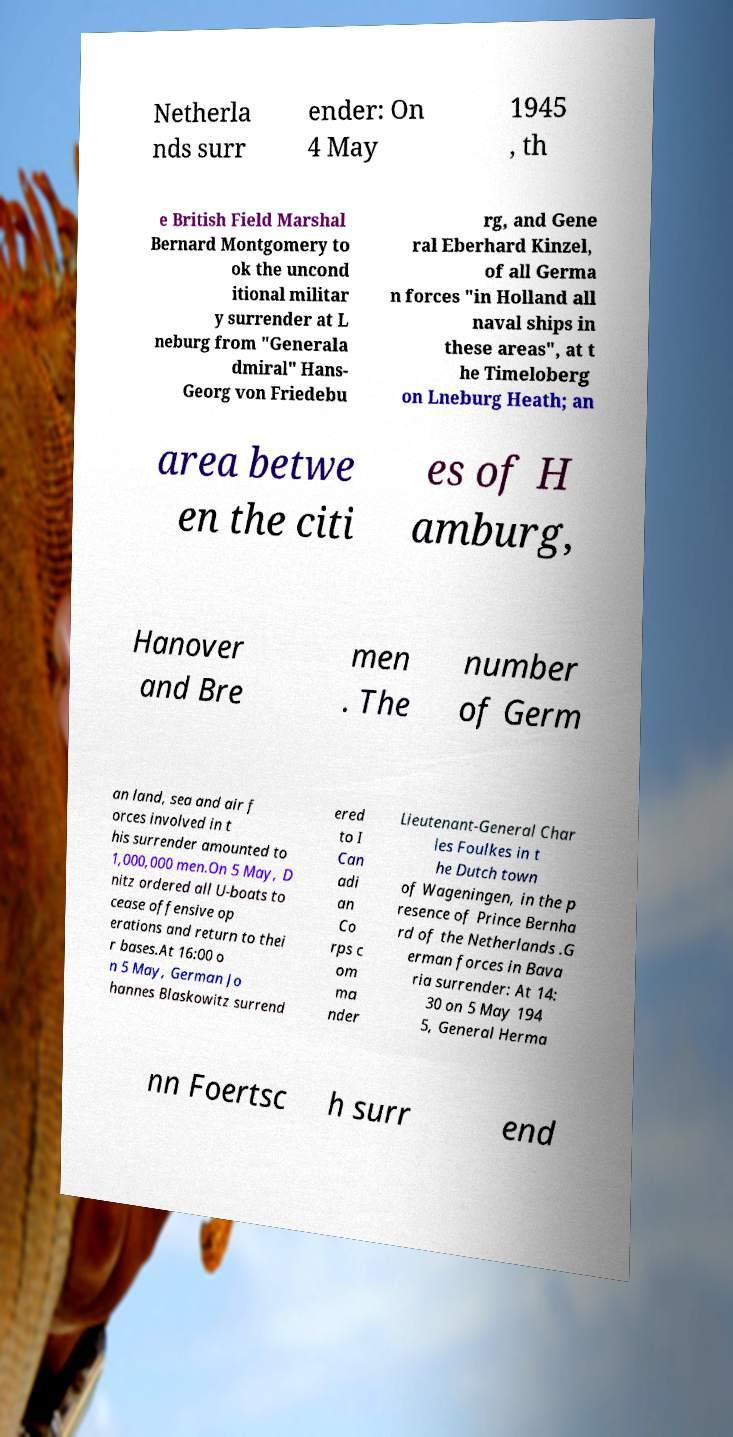Please identify and transcribe the text found in this image. Netherla nds surr ender: On 4 May 1945 , th e British Field Marshal Bernard Montgomery to ok the uncond itional militar y surrender at L neburg from "Generala dmiral" Hans- Georg von Friedebu rg, and Gene ral Eberhard Kinzel, of all Germa n forces "in Holland all naval ships in these areas", at t he Timeloberg on Lneburg Heath; an area betwe en the citi es of H amburg, Hanover and Bre men . The number of Germ an land, sea and air f orces involved in t his surrender amounted to 1,000,000 men.On 5 May, D nitz ordered all U-boats to cease offensive op erations and return to thei r bases.At 16:00 o n 5 May, German Jo hannes Blaskowitz surrend ered to I Can adi an Co rps c om ma nder Lieutenant-General Char les Foulkes in t he Dutch town of Wageningen, in the p resence of Prince Bernha rd of the Netherlands .G erman forces in Bava ria surrender: At 14: 30 on 5 May 194 5, General Herma nn Foertsc h surr end 